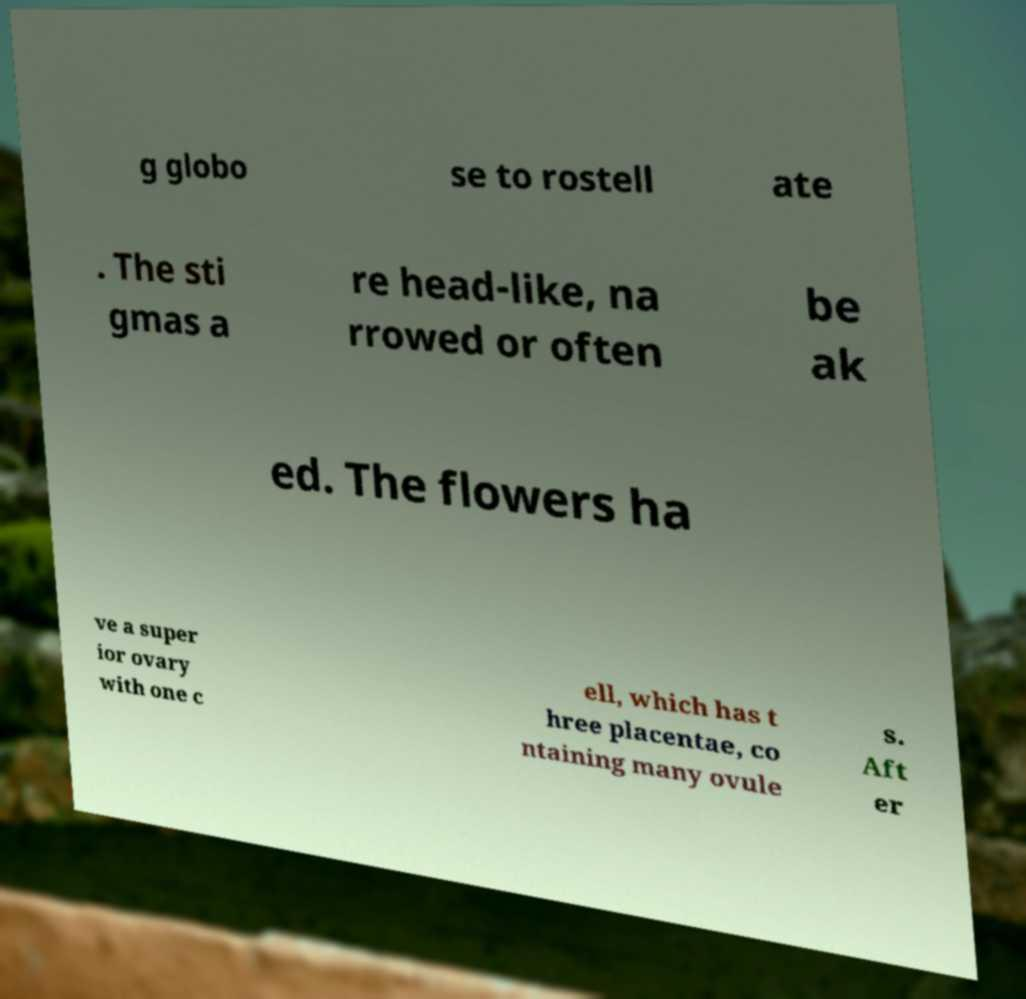Can you accurately transcribe the text from the provided image for me? g globo se to rostell ate . The sti gmas a re head-like, na rrowed or often be ak ed. The flowers ha ve a super ior ovary with one c ell, which has t hree placentae, co ntaining many ovule s. Aft er 